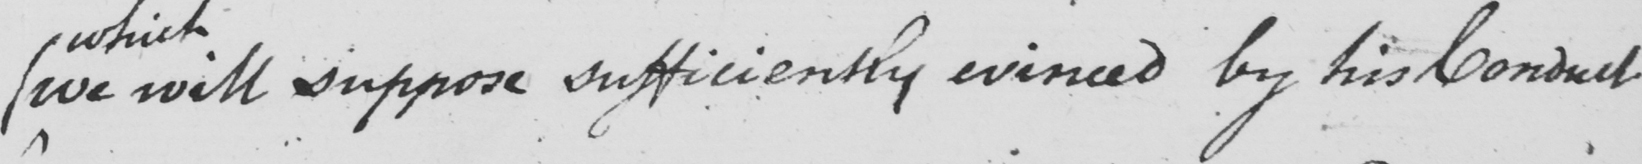Please provide the text content of this handwritten line. (  we will suppose sufficiently evinced by his Conduct 